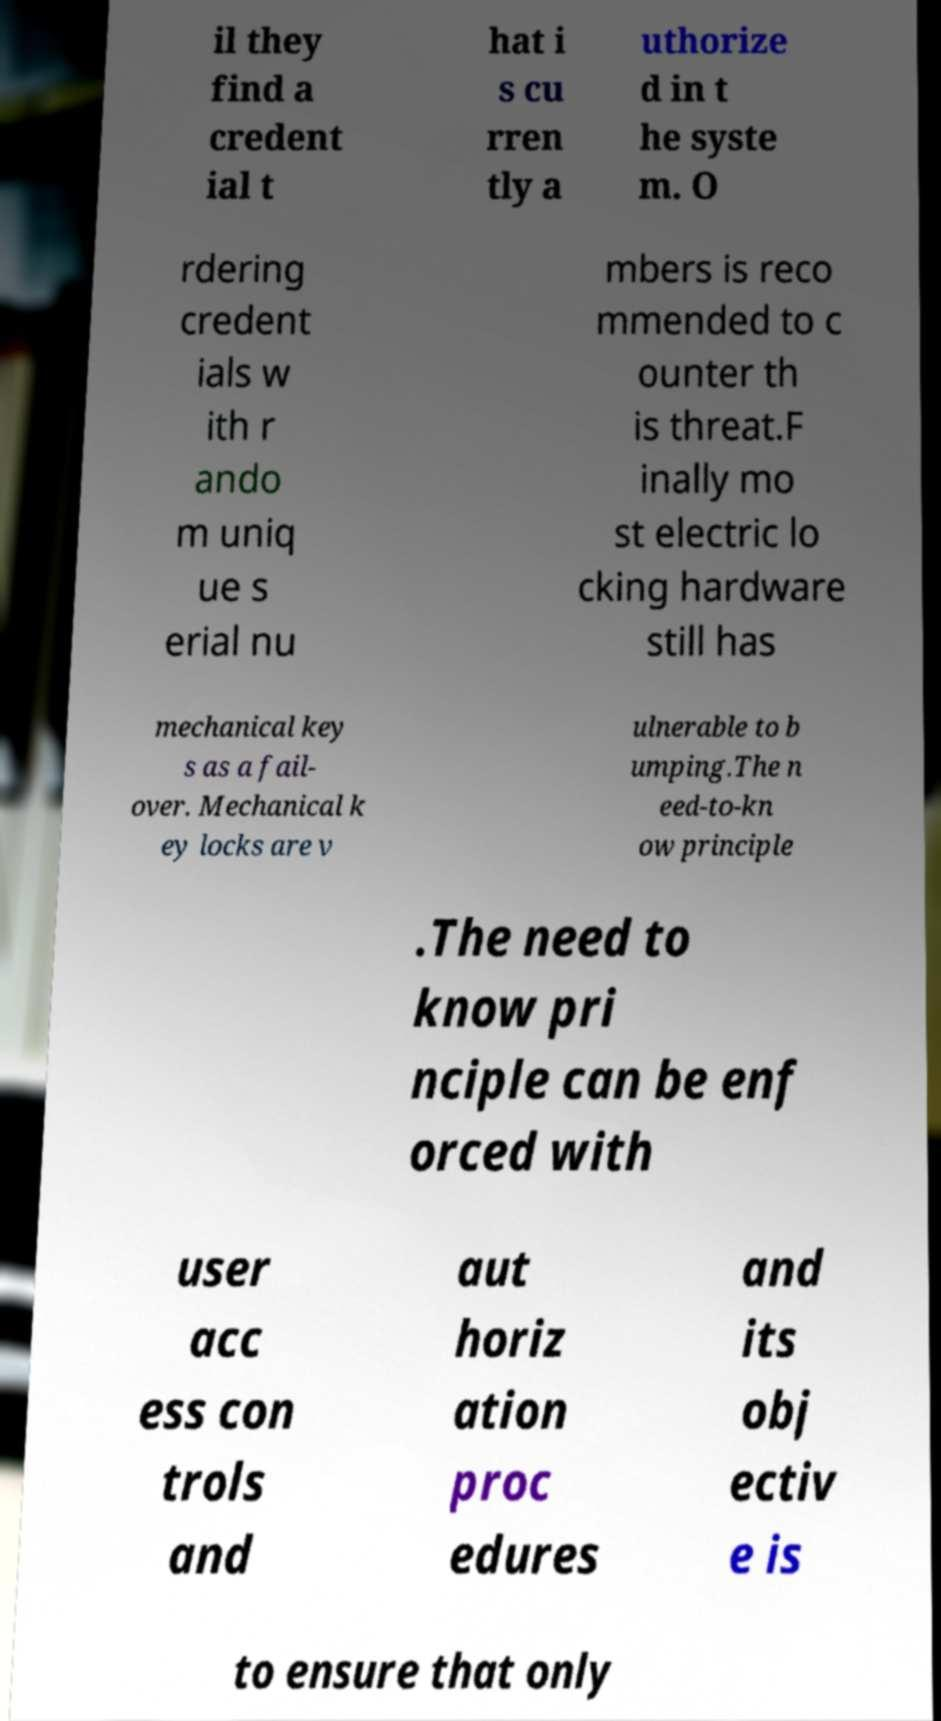Could you extract and type out the text from this image? il they find a credent ial t hat i s cu rren tly a uthorize d in t he syste m. O rdering credent ials w ith r ando m uniq ue s erial nu mbers is reco mmended to c ounter th is threat.F inally mo st electric lo cking hardware still has mechanical key s as a fail- over. Mechanical k ey locks are v ulnerable to b umping.The n eed-to-kn ow principle .The need to know pri nciple can be enf orced with user acc ess con trols and aut horiz ation proc edures and its obj ectiv e is to ensure that only 